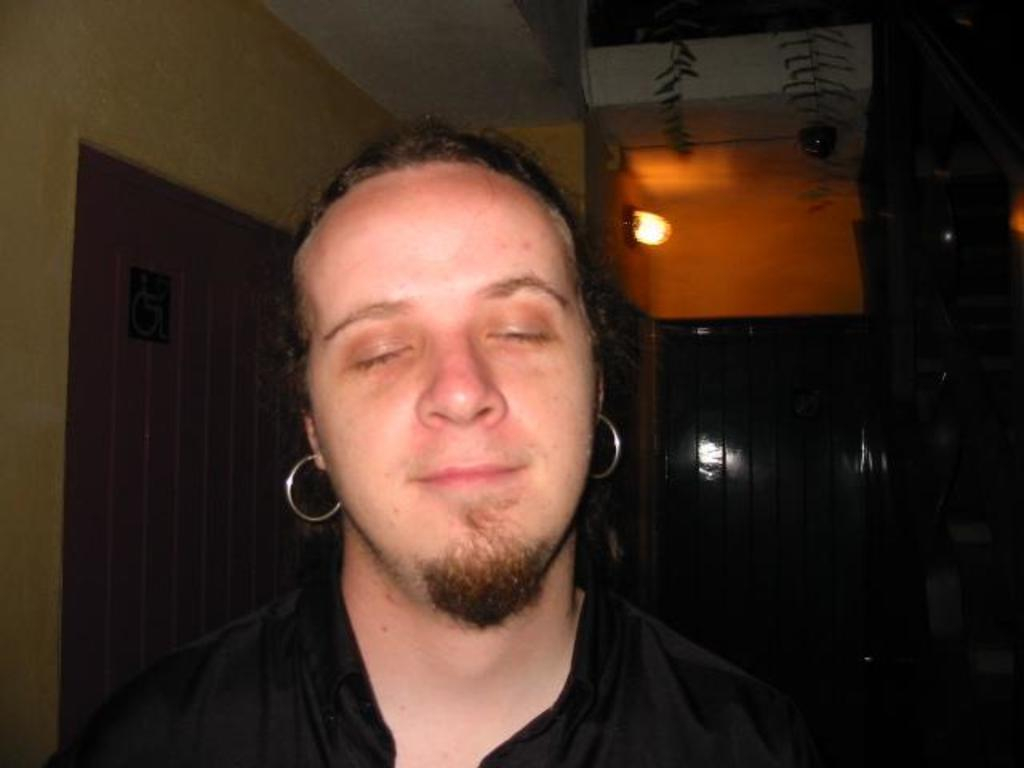What is the facial expression of the person in the image? The person in the image is smiling. What is the person not doing in the image? The person has closed their eyes. What can be seen in the background of the image? There is a light, a sign board, and a wall visible in the background. What time of day is it in the image, considering the root of a tree is visible? There is no root of a tree visible in the image, and therefore we cannot determine the time of day based on that information. 